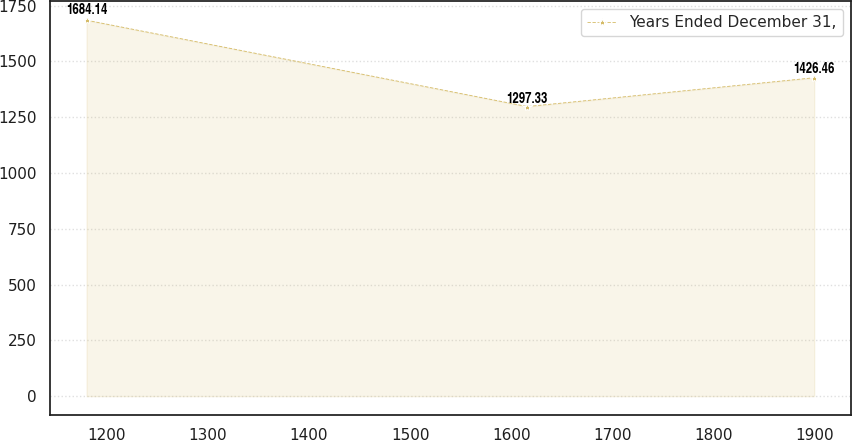<chart> <loc_0><loc_0><loc_500><loc_500><line_chart><ecel><fcel>Years Ended December 31,<nl><fcel>1180.06<fcel>1684.14<nl><fcel>1615.71<fcel>1297.33<nl><fcel>1899.52<fcel>1426.46<nl></chart> 